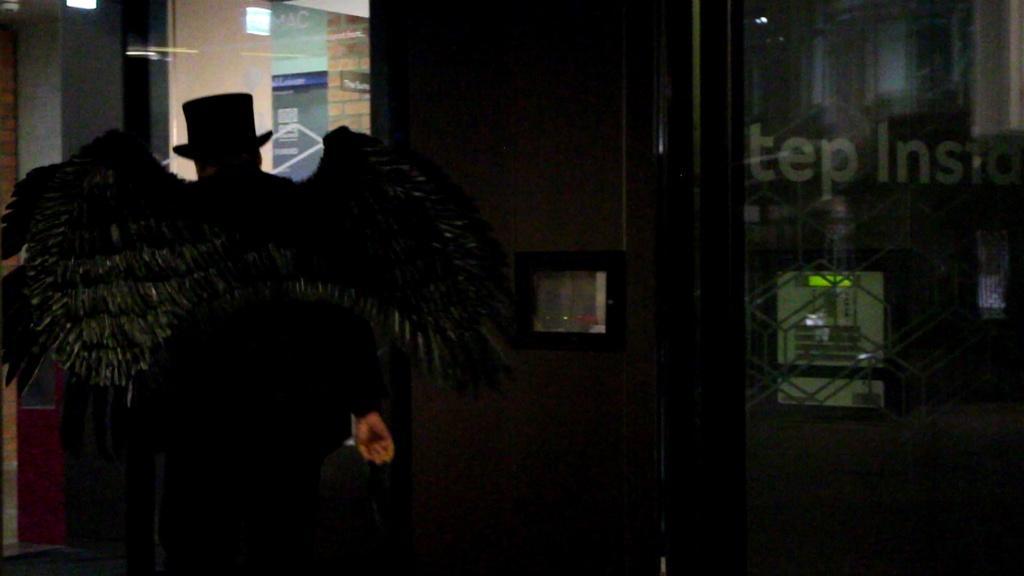Could you give a brief overview of what you see in this image? In the foreground, I can see a person in costume and a glass door. In the background, I can see wall paintings on a wall, some objects and lights on a rooftop. This picture might be taken during night. 